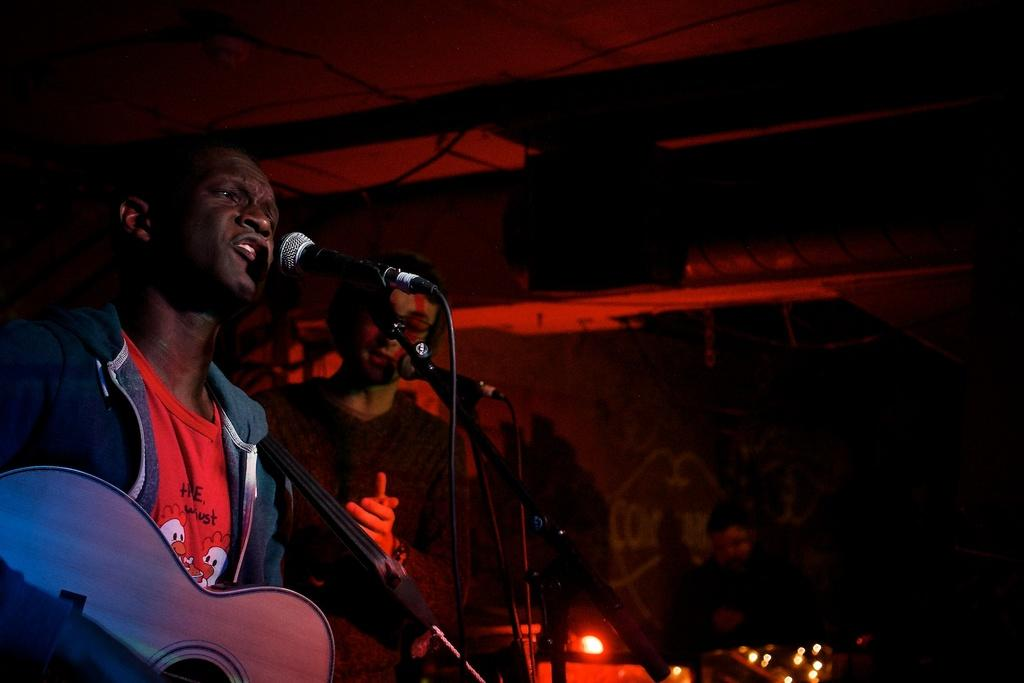What is the main activity of the person in the image? The person in the image is singing. What instrument is the person holding? The person is holding a guitar. What device is present for amplifying the person's voice? There is a microphone in the image. Is there anyone else visible in the image? Yes, there is another person standing nearby. What type of chain is being used to support the person's guitar in the image? There is no chain visible in the image; the person is simply holding the guitar. 